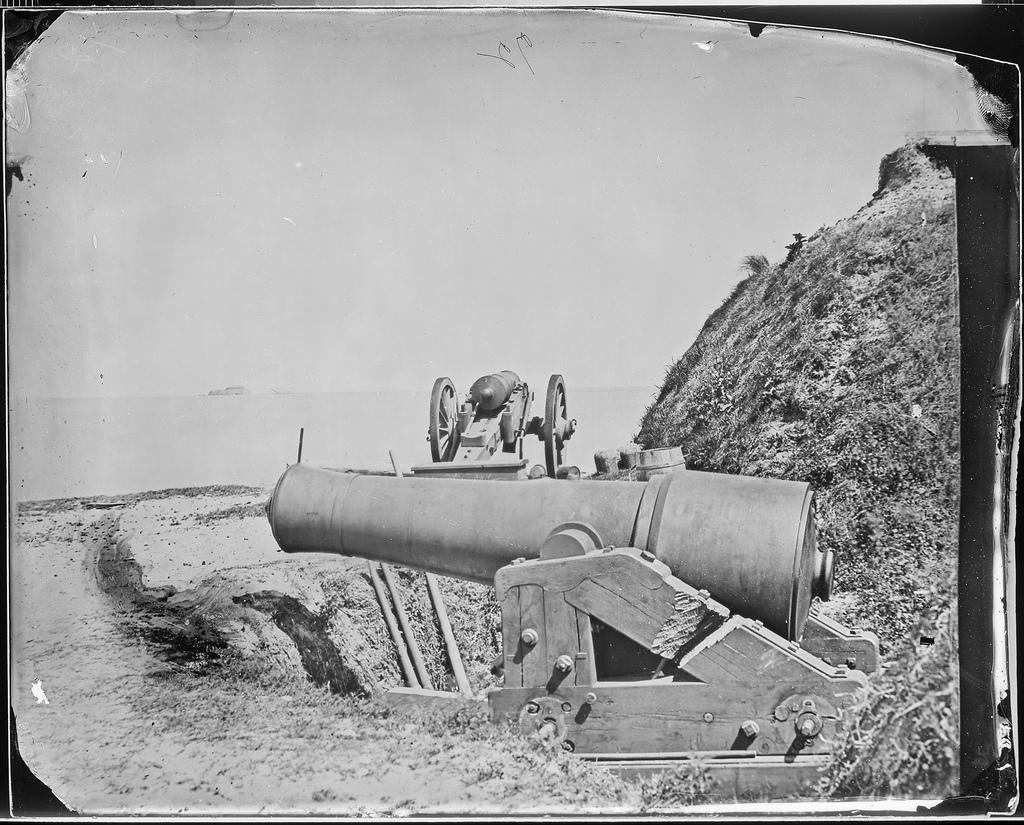What is the color scheme of the image? The image is an old black and white picture. What type of objects can be seen in the image? There are cannons in the image. What type of natural feature is present in the image? There is a hill in the image. What is visible in the background of the image? The sky is visible in the image. What type of growth can be seen on the cannons in the image? There is no growth visible on the cannons in the image, as it is a black and white picture and growth is not discernible in this context. What type of fiction is depicted in the image? The image is a photograph, not a work of fiction. --- 